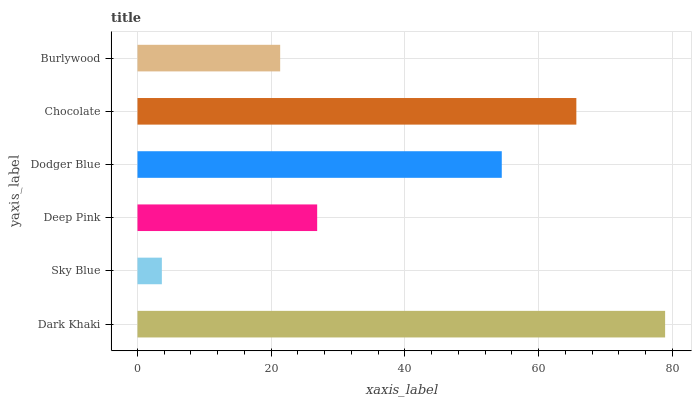Is Sky Blue the minimum?
Answer yes or no. Yes. Is Dark Khaki the maximum?
Answer yes or no. Yes. Is Deep Pink the minimum?
Answer yes or no. No. Is Deep Pink the maximum?
Answer yes or no. No. Is Deep Pink greater than Sky Blue?
Answer yes or no. Yes. Is Sky Blue less than Deep Pink?
Answer yes or no. Yes. Is Sky Blue greater than Deep Pink?
Answer yes or no. No. Is Deep Pink less than Sky Blue?
Answer yes or no. No. Is Dodger Blue the high median?
Answer yes or no. Yes. Is Deep Pink the low median?
Answer yes or no. Yes. Is Deep Pink the high median?
Answer yes or no. No. Is Dodger Blue the low median?
Answer yes or no. No. 